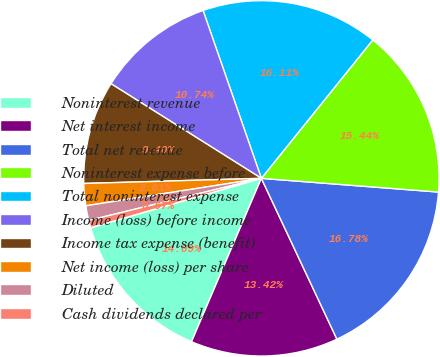Convert chart. <chart><loc_0><loc_0><loc_500><loc_500><pie_chart><fcel>Noninterest revenue<fcel>Net interest income<fcel>Total net revenue<fcel>Noninterest expense before<fcel>Total noninterest expense<fcel>Income (loss) before income<fcel>Income tax expense (benefit)<fcel>Net income (loss) per share<fcel>Diluted<fcel>Cash dividends declared per<nl><fcel>14.09%<fcel>13.42%<fcel>16.78%<fcel>15.44%<fcel>16.11%<fcel>10.74%<fcel>9.4%<fcel>2.01%<fcel>1.34%<fcel>0.67%<nl></chart> 